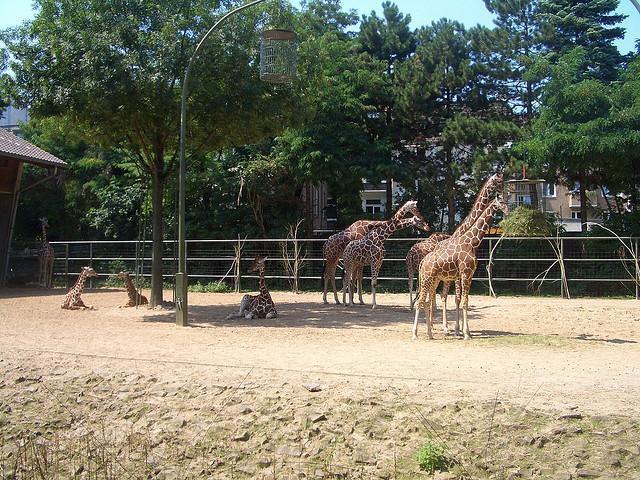How many giraffes are laying down?
Give a very brief answer. 3. How many giraffes are in the picture?
Give a very brief answer. 2. 